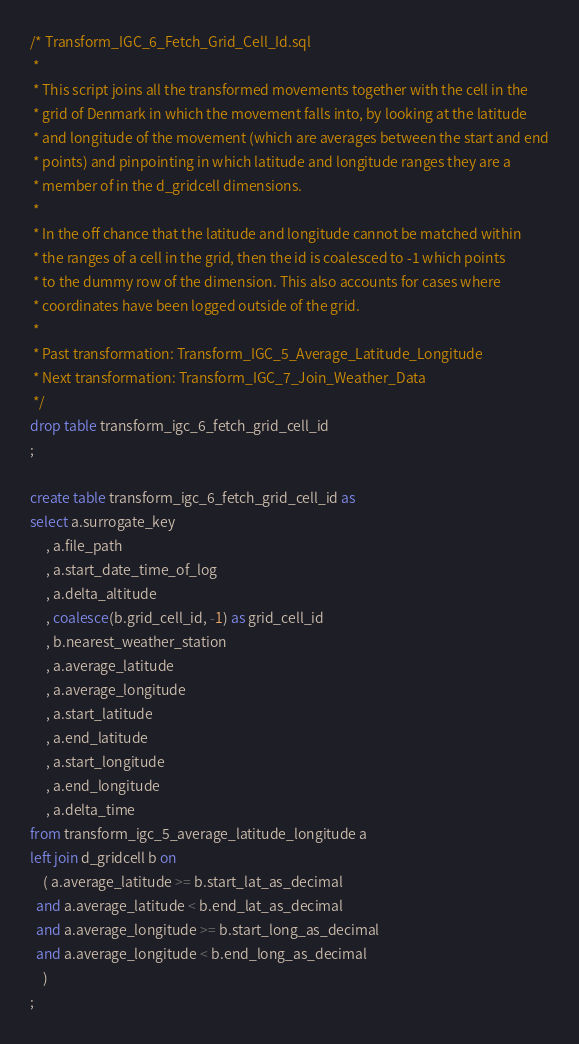<code> <loc_0><loc_0><loc_500><loc_500><_SQL_>/* Transform_IGC_6_Fetch_Grid_Cell_Id.sql
 *
 * This script joins all the transformed movements together with the cell in the
 * grid of Denmark in which the movement falls into, by looking at the latitude
 * and longitude of the movement (which are averages between the start and end
 * points) and pinpointing in which latitude and longitude ranges they are a
 * member of in the d_gridcell dimensions.
 *
 * In the off chance that the latitude and longitude cannot be matched within
 * the ranges of a cell in the grid, then the id is coalesced to -1 which points
 * to the dummy row of the dimension. This also accounts for cases where
 * coordinates have been logged outside of the grid.
 *
 * Past transformation: Transform_IGC_5_Average_Latitude_Longitude
 * Next transformation: Transform_IGC_7_Join_Weather_Data
 */
drop table transform_igc_6_fetch_grid_cell_id
;

create table transform_igc_6_fetch_grid_cell_id as
select a.surrogate_key
     , a.file_path
     , a.start_date_time_of_log
     , a.delta_altitude
     , coalesce(b.grid_cell_id, -1) as grid_cell_id
     , b.nearest_weather_station
     , a.average_latitude
     , a.average_longitude
     , a.start_latitude
     , a.end_latitude
     , a.start_longitude
     , a.end_longitude
     , a.delta_time
from transform_igc_5_average_latitude_longitude a
left join d_gridcell b on
    ( a.average_latitude >= b.start_lat_as_decimal
  and a.average_latitude < b.end_lat_as_decimal
  and a.average_longitude >= b.start_long_as_decimal
  and a.average_longitude < b.end_long_as_decimal
    )
;</code> 